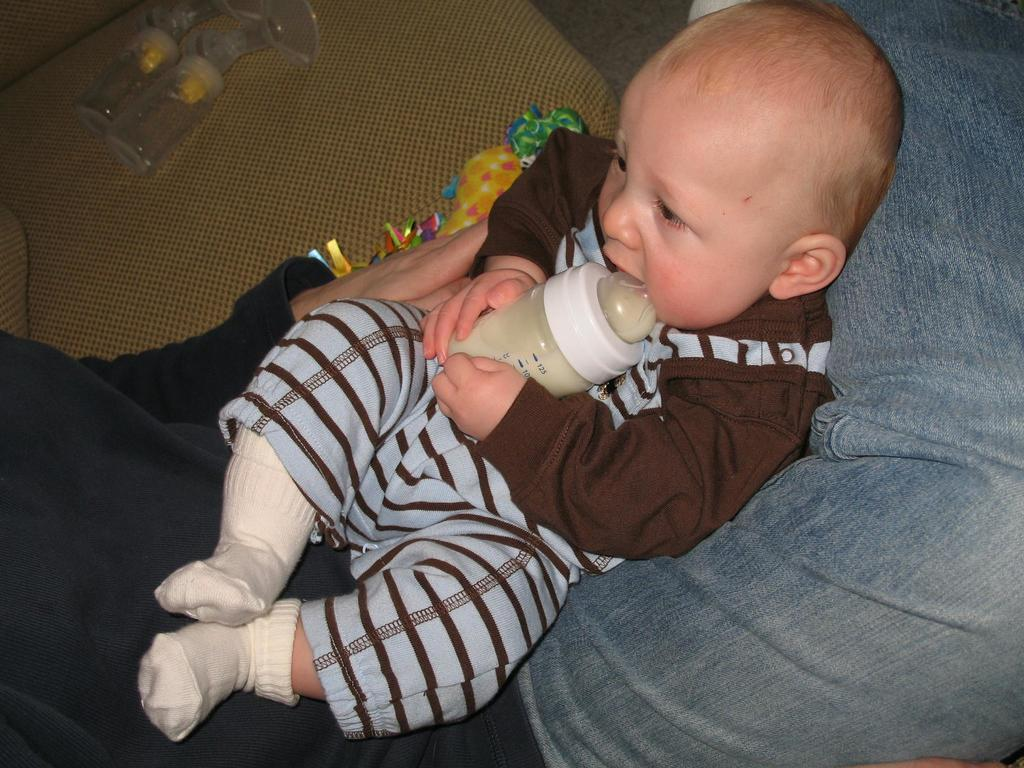What is the main subject of the image? There is a baby in the image. What is the baby holding in the image? The baby is holding a feeding bottle. Where is the baby positioned in the image? The baby is laying on a human lap. What can be seen at the top of the image? There are objects visible at the top of the image. What type of surface is visible in the image? There is a floor in the image. How many girls are participating in the protest visible in the image? There is no protest visible in the image; it features a baby holding a feeding bottle and laying on a human lap. 